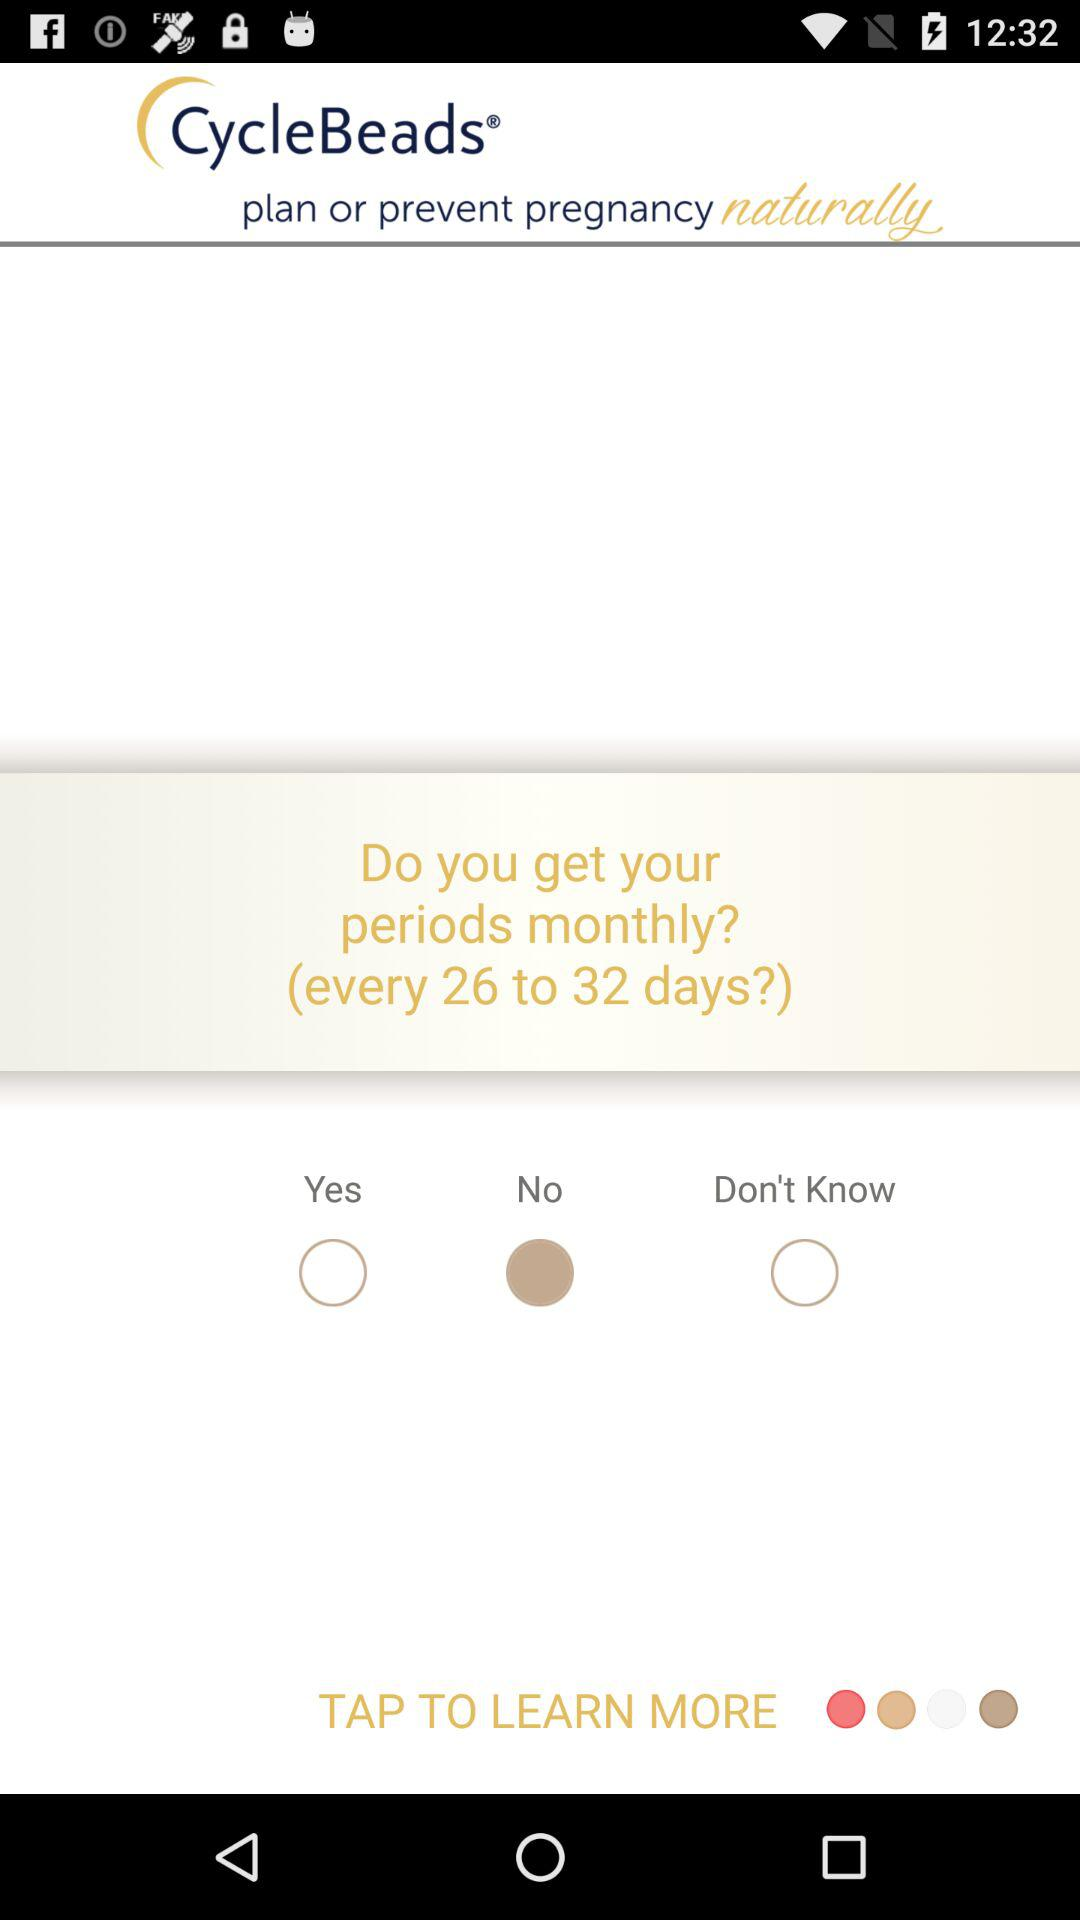Which option is selected for the question asked? The selected option is "No". 